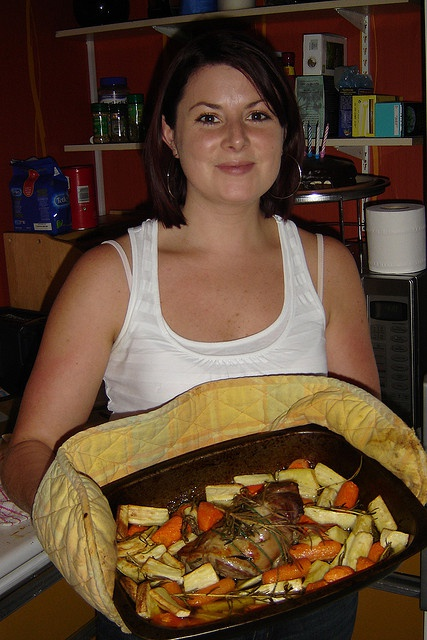Describe the objects in this image and their specific colors. I can see people in black, gray, darkgray, and maroon tones, microwave in black and gray tones, cake in black, gray, maroon, and olive tones, carrot in black, brown, maroon, and tan tones, and carrot in black, red, and maroon tones in this image. 